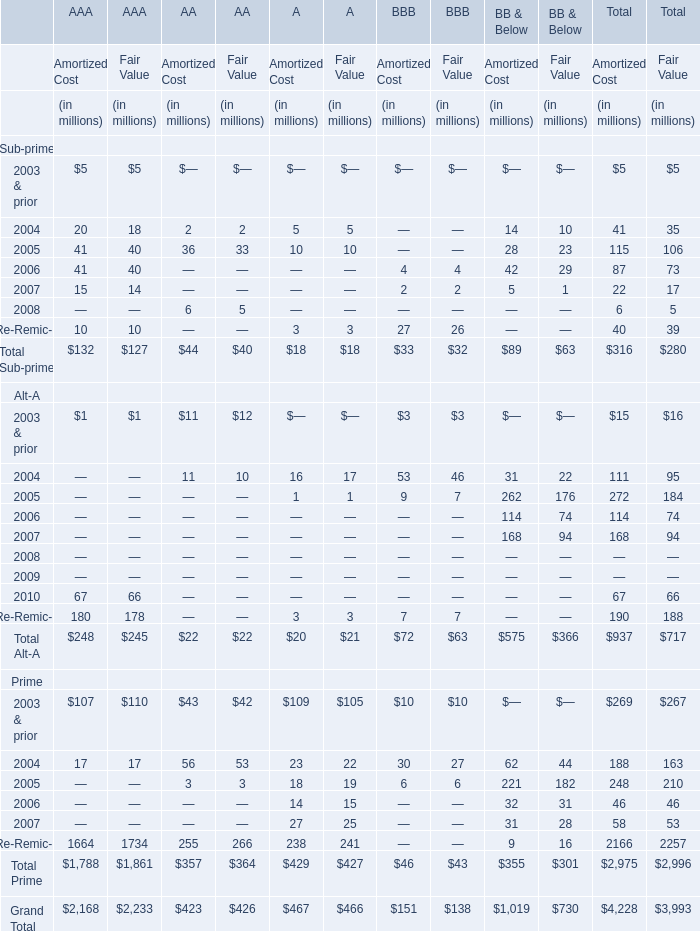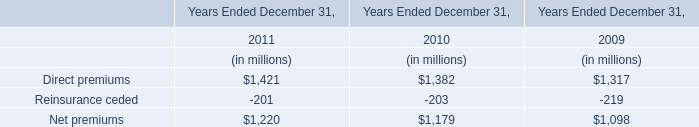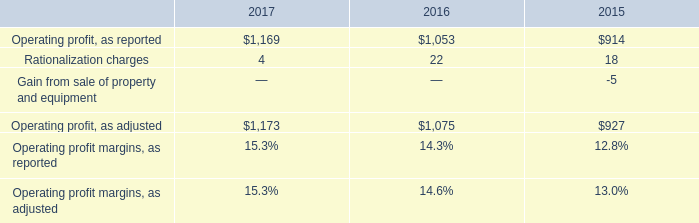In what year is Sub-prime of Total with Amortized Cost greater than 100? 
Answer: 2005. 